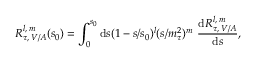<formula> <loc_0><loc_0><loc_500><loc_500>R _ { \tau , \, V / A } ^ { l , \, m } ( s _ { 0 } ) = \int _ { 0 } ^ { s _ { 0 } } d s ( 1 - s / s _ { 0 } ) ^ { l } ( s / m _ { \tau } ^ { 2 } ) ^ { m } \, \frac { d R _ { \tau , \, V / A } ^ { l , \, m } } { d s } ,</formula> 